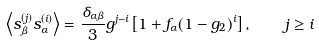Convert formula to latex. <formula><loc_0><loc_0><loc_500><loc_500>\left \langle s ^ { ( j ) } _ { \beta } s ^ { ( i ) } _ { \alpha } \right \rangle = \frac { \delta _ { \alpha \beta } } { 3 } g ^ { j - i } \left [ 1 + f _ { \alpha } ( 1 - g _ { 2 } ) ^ { i } \right ] , \quad j \geq i</formula> 